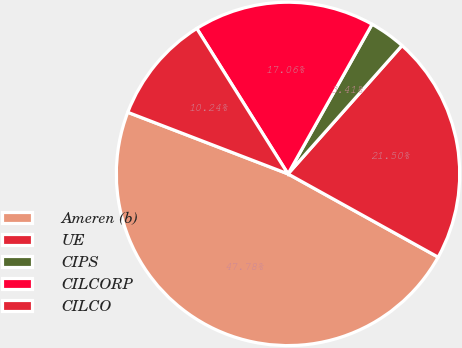Convert chart. <chart><loc_0><loc_0><loc_500><loc_500><pie_chart><fcel>Ameren (b)<fcel>UE<fcel>CIPS<fcel>CILCORP<fcel>CILCO<nl><fcel>47.78%<fcel>21.5%<fcel>3.41%<fcel>17.06%<fcel>10.24%<nl></chart> 